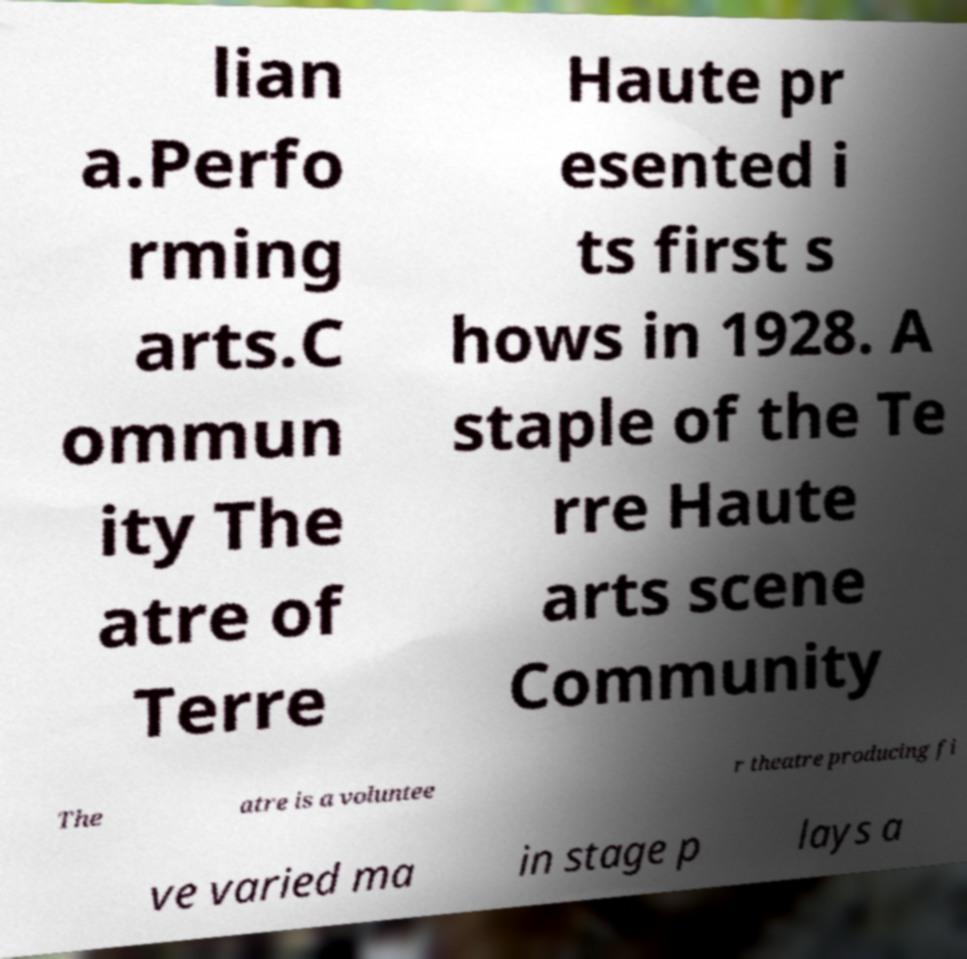Can you read and provide the text displayed in the image?This photo seems to have some interesting text. Can you extract and type it out for me? lian a.Perfo rming arts.C ommun ity The atre of Terre Haute pr esented i ts first s hows in 1928. A staple of the Te rre Haute arts scene Community The atre is a voluntee r theatre producing fi ve varied ma in stage p lays a 